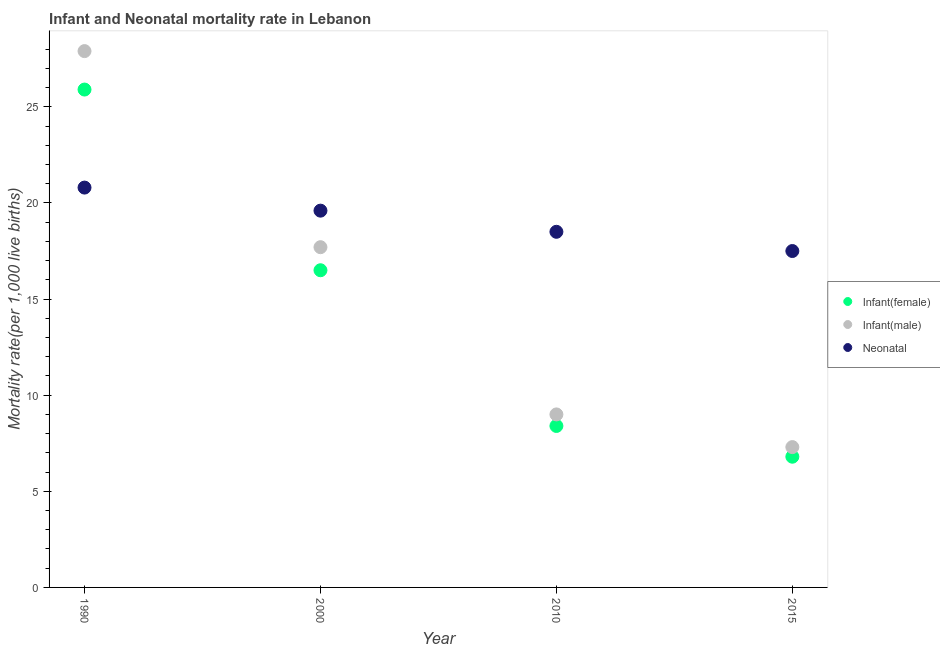Is the number of dotlines equal to the number of legend labels?
Keep it short and to the point. Yes. Across all years, what is the maximum infant mortality rate(female)?
Keep it short and to the point. 25.9. In which year was the infant mortality rate(female) minimum?
Provide a succinct answer. 2015. What is the total infant mortality rate(female) in the graph?
Your answer should be very brief. 57.6. What is the difference between the infant mortality rate(female) in 1990 and that in 2015?
Your response must be concise. 19.1. In the year 1990, what is the difference between the neonatal mortality rate and infant mortality rate(male)?
Give a very brief answer. -7.1. What is the ratio of the infant mortality rate(female) in 2000 to that in 2015?
Provide a succinct answer. 2.43. Is the neonatal mortality rate in 2010 less than that in 2015?
Give a very brief answer. No. Is the difference between the infant mortality rate(male) in 2010 and 2015 greater than the difference between the infant mortality rate(female) in 2010 and 2015?
Your response must be concise. Yes. What is the difference between the highest and the second highest neonatal mortality rate?
Offer a very short reply. 1.2. What is the difference between the highest and the lowest infant mortality rate(male)?
Offer a very short reply. 20.6. In how many years, is the infant mortality rate(male) greater than the average infant mortality rate(male) taken over all years?
Your answer should be compact. 2. Is the infant mortality rate(male) strictly greater than the infant mortality rate(female) over the years?
Provide a short and direct response. Yes. How many dotlines are there?
Make the answer very short. 3. How many years are there in the graph?
Give a very brief answer. 4. Are the values on the major ticks of Y-axis written in scientific E-notation?
Make the answer very short. No. Where does the legend appear in the graph?
Keep it short and to the point. Center right. What is the title of the graph?
Your response must be concise. Infant and Neonatal mortality rate in Lebanon. What is the label or title of the X-axis?
Provide a short and direct response. Year. What is the label or title of the Y-axis?
Your answer should be very brief. Mortality rate(per 1,0 live births). What is the Mortality rate(per 1,000 live births) of Infant(female) in 1990?
Ensure brevity in your answer.  25.9. What is the Mortality rate(per 1,000 live births) of Infant(male) in 1990?
Provide a succinct answer. 27.9. What is the Mortality rate(per 1,000 live births) of Neonatal  in 1990?
Your response must be concise. 20.8. What is the Mortality rate(per 1,000 live births) of Neonatal  in 2000?
Offer a very short reply. 19.6. What is the Mortality rate(per 1,000 live births) of Neonatal  in 2010?
Your answer should be very brief. 18.5. What is the Mortality rate(per 1,000 live births) in Infant(female) in 2015?
Make the answer very short. 6.8. Across all years, what is the maximum Mortality rate(per 1,000 live births) in Infant(female)?
Your answer should be very brief. 25.9. Across all years, what is the maximum Mortality rate(per 1,000 live births) in Infant(male)?
Keep it short and to the point. 27.9. Across all years, what is the maximum Mortality rate(per 1,000 live births) of Neonatal ?
Provide a succinct answer. 20.8. Across all years, what is the minimum Mortality rate(per 1,000 live births) of Infant(male)?
Keep it short and to the point. 7.3. What is the total Mortality rate(per 1,000 live births) of Infant(female) in the graph?
Your answer should be very brief. 57.6. What is the total Mortality rate(per 1,000 live births) in Infant(male) in the graph?
Offer a very short reply. 61.9. What is the total Mortality rate(per 1,000 live births) of Neonatal  in the graph?
Offer a very short reply. 76.4. What is the difference between the Mortality rate(per 1,000 live births) in Infant(female) in 1990 and that in 2000?
Provide a succinct answer. 9.4. What is the difference between the Mortality rate(per 1,000 live births) in Infant(male) in 1990 and that in 2000?
Keep it short and to the point. 10.2. What is the difference between the Mortality rate(per 1,000 live births) of Infant(female) in 1990 and that in 2010?
Keep it short and to the point. 17.5. What is the difference between the Mortality rate(per 1,000 live births) in Infant(male) in 1990 and that in 2010?
Provide a short and direct response. 18.9. What is the difference between the Mortality rate(per 1,000 live births) in Neonatal  in 1990 and that in 2010?
Offer a very short reply. 2.3. What is the difference between the Mortality rate(per 1,000 live births) in Infant(male) in 1990 and that in 2015?
Ensure brevity in your answer.  20.6. What is the difference between the Mortality rate(per 1,000 live births) in Neonatal  in 1990 and that in 2015?
Ensure brevity in your answer.  3.3. What is the difference between the Mortality rate(per 1,000 live births) in Infant(female) in 2000 and that in 2010?
Ensure brevity in your answer.  8.1. What is the difference between the Mortality rate(per 1,000 live births) of Infant(male) in 2000 and that in 2010?
Offer a terse response. 8.7. What is the difference between the Mortality rate(per 1,000 live births) of Infant(female) in 2000 and that in 2015?
Your response must be concise. 9.7. What is the difference between the Mortality rate(per 1,000 live births) in Neonatal  in 2000 and that in 2015?
Offer a very short reply. 2.1. What is the difference between the Mortality rate(per 1,000 live births) of Infant(female) in 2010 and that in 2015?
Provide a short and direct response. 1.6. What is the difference between the Mortality rate(per 1,000 live births) in Infant(male) in 2010 and that in 2015?
Offer a very short reply. 1.7. What is the difference between the Mortality rate(per 1,000 live births) of Neonatal  in 2010 and that in 2015?
Your answer should be very brief. 1. What is the difference between the Mortality rate(per 1,000 live births) of Infant(female) in 1990 and the Mortality rate(per 1,000 live births) of Infant(male) in 2000?
Offer a terse response. 8.2. What is the difference between the Mortality rate(per 1,000 live births) of Infant(female) in 1990 and the Mortality rate(per 1,000 live births) of Neonatal  in 2000?
Provide a succinct answer. 6.3. What is the difference between the Mortality rate(per 1,000 live births) in Infant(male) in 1990 and the Mortality rate(per 1,000 live births) in Neonatal  in 2000?
Your answer should be compact. 8.3. What is the difference between the Mortality rate(per 1,000 live births) of Infant(female) in 1990 and the Mortality rate(per 1,000 live births) of Neonatal  in 2010?
Make the answer very short. 7.4. What is the difference between the Mortality rate(per 1,000 live births) in Infant(male) in 1990 and the Mortality rate(per 1,000 live births) in Neonatal  in 2010?
Make the answer very short. 9.4. What is the difference between the Mortality rate(per 1,000 live births) in Infant(female) in 1990 and the Mortality rate(per 1,000 live births) in Neonatal  in 2015?
Provide a succinct answer. 8.4. What is the difference between the Mortality rate(per 1,000 live births) in Infant(female) in 2000 and the Mortality rate(per 1,000 live births) in Infant(male) in 2010?
Give a very brief answer. 7.5. What is the difference between the Mortality rate(per 1,000 live births) in Infant(female) in 2000 and the Mortality rate(per 1,000 live births) in Neonatal  in 2010?
Make the answer very short. -2. What is the difference between the Mortality rate(per 1,000 live births) in Infant(female) in 2010 and the Mortality rate(per 1,000 live births) in Neonatal  in 2015?
Your response must be concise. -9.1. What is the difference between the Mortality rate(per 1,000 live births) in Infant(male) in 2010 and the Mortality rate(per 1,000 live births) in Neonatal  in 2015?
Offer a terse response. -8.5. What is the average Mortality rate(per 1,000 live births) in Infant(male) per year?
Provide a short and direct response. 15.47. What is the average Mortality rate(per 1,000 live births) of Neonatal  per year?
Keep it short and to the point. 19.1. In the year 1990, what is the difference between the Mortality rate(per 1,000 live births) of Infant(female) and Mortality rate(per 1,000 live births) of Infant(male)?
Provide a short and direct response. -2. In the year 1990, what is the difference between the Mortality rate(per 1,000 live births) in Infant(female) and Mortality rate(per 1,000 live births) in Neonatal ?
Offer a very short reply. 5.1. In the year 1990, what is the difference between the Mortality rate(per 1,000 live births) of Infant(male) and Mortality rate(per 1,000 live births) of Neonatal ?
Give a very brief answer. 7.1. In the year 2000, what is the difference between the Mortality rate(per 1,000 live births) of Infant(female) and Mortality rate(per 1,000 live births) of Infant(male)?
Your answer should be very brief. -1.2. In the year 2000, what is the difference between the Mortality rate(per 1,000 live births) of Infant(female) and Mortality rate(per 1,000 live births) of Neonatal ?
Offer a terse response. -3.1. In the year 2010, what is the difference between the Mortality rate(per 1,000 live births) in Infant(female) and Mortality rate(per 1,000 live births) in Neonatal ?
Offer a very short reply. -10.1. In the year 2010, what is the difference between the Mortality rate(per 1,000 live births) in Infant(male) and Mortality rate(per 1,000 live births) in Neonatal ?
Make the answer very short. -9.5. In the year 2015, what is the difference between the Mortality rate(per 1,000 live births) in Infant(female) and Mortality rate(per 1,000 live births) in Infant(male)?
Provide a short and direct response. -0.5. In the year 2015, what is the difference between the Mortality rate(per 1,000 live births) of Infant(female) and Mortality rate(per 1,000 live births) of Neonatal ?
Offer a very short reply. -10.7. In the year 2015, what is the difference between the Mortality rate(per 1,000 live births) of Infant(male) and Mortality rate(per 1,000 live births) of Neonatal ?
Your answer should be very brief. -10.2. What is the ratio of the Mortality rate(per 1,000 live births) of Infant(female) in 1990 to that in 2000?
Offer a terse response. 1.57. What is the ratio of the Mortality rate(per 1,000 live births) of Infant(male) in 1990 to that in 2000?
Provide a short and direct response. 1.58. What is the ratio of the Mortality rate(per 1,000 live births) of Neonatal  in 1990 to that in 2000?
Make the answer very short. 1.06. What is the ratio of the Mortality rate(per 1,000 live births) in Infant(female) in 1990 to that in 2010?
Make the answer very short. 3.08. What is the ratio of the Mortality rate(per 1,000 live births) in Infant(male) in 1990 to that in 2010?
Give a very brief answer. 3.1. What is the ratio of the Mortality rate(per 1,000 live births) of Neonatal  in 1990 to that in 2010?
Your answer should be very brief. 1.12. What is the ratio of the Mortality rate(per 1,000 live births) in Infant(female) in 1990 to that in 2015?
Your response must be concise. 3.81. What is the ratio of the Mortality rate(per 1,000 live births) of Infant(male) in 1990 to that in 2015?
Your answer should be compact. 3.82. What is the ratio of the Mortality rate(per 1,000 live births) in Neonatal  in 1990 to that in 2015?
Your response must be concise. 1.19. What is the ratio of the Mortality rate(per 1,000 live births) in Infant(female) in 2000 to that in 2010?
Give a very brief answer. 1.96. What is the ratio of the Mortality rate(per 1,000 live births) in Infant(male) in 2000 to that in 2010?
Make the answer very short. 1.97. What is the ratio of the Mortality rate(per 1,000 live births) of Neonatal  in 2000 to that in 2010?
Ensure brevity in your answer.  1.06. What is the ratio of the Mortality rate(per 1,000 live births) in Infant(female) in 2000 to that in 2015?
Offer a very short reply. 2.43. What is the ratio of the Mortality rate(per 1,000 live births) of Infant(male) in 2000 to that in 2015?
Offer a terse response. 2.42. What is the ratio of the Mortality rate(per 1,000 live births) of Neonatal  in 2000 to that in 2015?
Give a very brief answer. 1.12. What is the ratio of the Mortality rate(per 1,000 live births) of Infant(female) in 2010 to that in 2015?
Make the answer very short. 1.24. What is the ratio of the Mortality rate(per 1,000 live births) of Infant(male) in 2010 to that in 2015?
Give a very brief answer. 1.23. What is the ratio of the Mortality rate(per 1,000 live births) of Neonatal  in 2010 to that in 2015?
Your answer should be compact. 1.06. What is the difference between the highest and the second highest Mortality rate(per 1,000 live births) of Infant(male)?
Provide a short and direct response. 10.2. What is the difference between the highest and the lowest Mortality rate(per 1,000 live births) of Infant(male)?
Offer a terse response. 20.6. What is the difference between the highest and the lowest Mortality rate(per 1,000 live births) of Neonatal ?
Your answer should be compact. 3.3. 